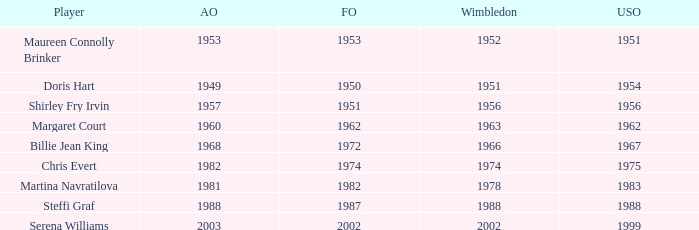What year did Martina Navratilova win Wimbledon? 1978.0. 